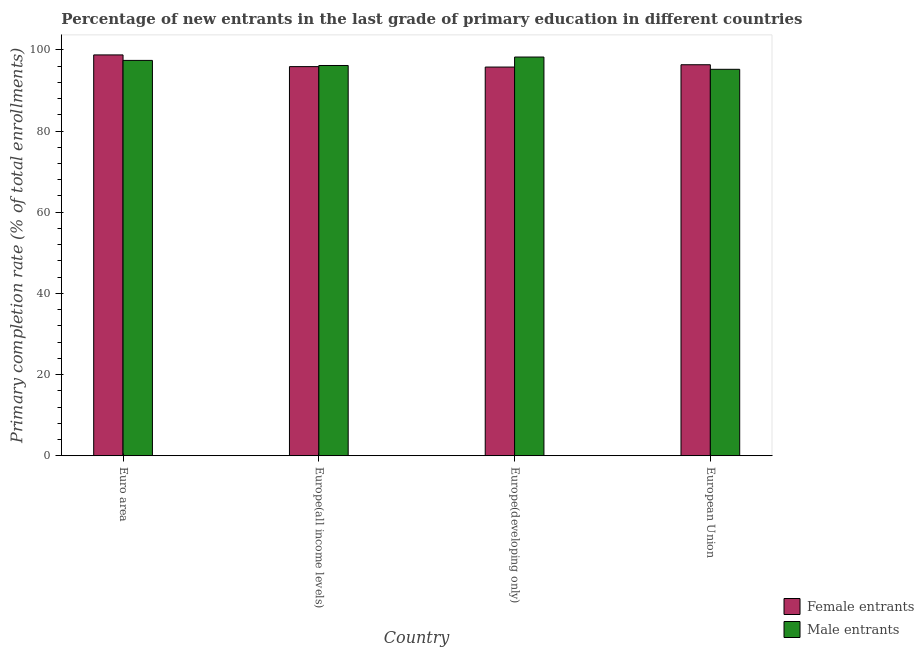Are the number of bars per tick equal to the number of legend labels?
Your answer should be very brief. Yes. Are the number of bars on each tick of the X-axis equal?
Give a very brief answer. Yes. How many bars are there on the 3rd tick from the left?
Provide a short and direct response. 2. How many bars are there on the 3rd tick from the right?
Offer a very short reply. 2. What is the label of the 3rd group of bars from the left?
Your answer should be very brief. Europe(developing only). In how many cases, is the number of bars for a given country not equal to the number of legend labels?
Offer a very short reply. 0. What is the primary completion rate of male entrants in Europe(all income levels)?
Provide a succinct answer. 96.15. Across all countries, what is the maximum primary completion rate of female entrants?
Ensure brevity in your answer.  98.76. Across all countries, what is the minimum primary completion rate of female entrants?
Your answer should be very brief. 95.77. In which country was the primary completion rate of female entrants maximum?
Provide a succinct answer. Euro area. In which country was the primary completion rate of male entrants minimum?
Your response must be concise. European Union. What is the total primary completion rate of female entrants in the graph?
Your response must be concise. 386.74. What is the difference between the primary completion rate of female entrants in Europe(all income levels) and that in Europe(developing only)?
Offer a terse response. 0.11. What is the difference between the primary completion rate of female entrants in Euro area and the primary completion rate of male entrants in Europe(all income levels)?
Provide a succinct answer. 2.61. What is the average primary completion rate of female entrants per country?
Keep it short and to the point. 96.69. What is the difference between the primary completion rate of female entrants and primary completion rate of male entrants in Europe(developing only)?
Provide a short and direct response. -2.47. What is the ratio of the primary completion rate of male entrants in Euro area to that in Europe(developing only)?
Offer a very short reply. 0.99. Is the difference between the primary completion rate of female entrants in Euro area and Europe(developing only) greater than the difference between the primary completion rate of male entrants in Euro area and Europe(developing only)?
Provide a succinct answer. Yes. What is the difference between the highest and the second highest primary completion rate of male entrants?
Your answer should be compact. 0.83. What is the difference between the highest and the lowest primary completion rate of female entrants?
Your response must be concise. 2.99. In how many countries, is the primary completion rate of male entrants greater than the average primary completion rate of male entrants taken over all countries?
Offer a very short reply. 2. What does the 2nd bar from the left in Euro area represents?
Provide a succinct answer. Male entrants. What does the 1st bar from the right in Europe(all income levels) represents?
Offer a very short reply. Male entrants. What is the difference between two consecutive major ticks on the Y-axis?
Give a very brief answer. 20. How many legend labels are there?
Keep it short and to the point. 2. How are the legend labels stacked?
Ensure brevity in your answer.  Vertical. What is the title of the graph?
Offer a very short reply. Percentage of new entrants in the last grade of primary education in different countries. Does "Unregistered firms" appear as one of the legend labels in the graph?
Keep it short and to the point. No. What is the label or title of the X-axis?
Provide a succinct answer. Country. What is the label or title of the Y-axis?
Your answer should be compact. Primary completion rate (% of total enrollments). What is the Primary completion rate (% of total enrollments) in Female entrants in Euro area?
Provide a short and direct response. 98.76. What is the Primary completion rate (% of total enrollments) in Male entrants in Euro area?
Your answer should be compact. 97.41. What is the Primary completion rate (% of total enrollments) of Female entrants in Europe(all income levels)?
Provide a short and direct response. 95.87. What is the Primary completion rate (% of total enrollments) of Male entrants in Europe(all income levels)?
Keep it short and to the point. 96.15. What is the Primary completion rate (% of total enrollments) of Female entrants in Europe(developing only)?
Your answer should be very brief. 95.77. What is the Primary completion rate (% of total enrollments) of Male entrants in Europe(developing only)?
Your response must be concise. 98.23. What is the Primary completion rate (% of total enrollments) of Female entrants in European Union?
Provide a succinct answer. 96.34. What is the Primary completion rate (% of total enrollments) in Male entrants in European Union?
Your answer should be very brief. 95.21. Across all countries, what is the maximum Primary completion rate (% of total enrollments) of Female entrants?
Provide a short and direct response. 98.76. Across all countries, what is the maximum Primary completion rate (% of total enrollments) of Male entrants?
Your response must be concise. 98.23. Across all countries, what is the minimum Primary completion rate (% of total enrollments) of Female entrants?
Provide a short and direct response. 95.77. Across all countries, what is the minimum Primary completion rate (% of total enrollments) of Male entrants?
Your answer should be very brief. 95.21. What is the total Primary completion rate (% of total enrollments) of Female entrants in the graph?
Your response must be concise. 386.74. What is the total Primary completion rate (% of total enrollments) of Male entrants in the graph?
Offer a terse response. 387.01. What is the difference between the Primary completion rate (% of total enrollments) of Female entrants in Euro area and that in Europe(all income levels)?
Provide a short and direct response. 2.88. What is the difference between the Primary completion rate (% of total enrollments) in Male entrants in Euro area and that in Europe(all income levels)?
Provide a succinct answer. 1.25. What is the difference between the Primary completion rate (% of total enrollments) of Female entrants in Euro area and that in Europe(developing only)?
Offer a very short reply. 2.99. What is the difference between the Primary completion rate (% of total enrollments) of Male entrants in Euro area and that in Europe(developing only)?
Make the answer very short. -0.83. What is the difference between the Primary completion rate (% of total enrollments) in Female entrants in Euro area and that in European Union?
Keep it short and to the point. 2.42. What is the difference between the Primary completion rate (% of total enrollments) in Male entrants in Euro area and that in European Union?
Your answer should be compact. 2.19. What is the difference between the Primary completion rate (% of total enrollments) of Female entrants in Europe(all income levels) and that in Europe(developing only)?
Your answer should be compact. 0.11. What is the difference between the Primary completion rate (% of total enrollments) of Male entrants in Europe(all income levels) and that in Europe(developing only)?
Provide a short and direct response. -2.08. What is the difference between the Primary completion rate (% of total enrollments) in Female entrants in Europe(all income levels) and that in European Union?
Keep it short and to the point. -0.46. What is the difference between the Primary completion rate (% of total enrollments) of Male entrants in Europe(all income levels) and that in European Union?
Your answer should be very brief. 0.94. What is the difference between the Primary completion rate (% of total enrollments) in Female entrants in Europe(developing only) and that in European Union?
Provide a succinct answer. -0.57. What is the difference between the Primary completion rate (% of total enrollments) in Male entrants in Europe(developing only) and that in European Union?
Keep it short and to the point. 3.02. What is the difference between the Primary completion rate (% of total enrollments) of Female entrants in Euro area and the Primary completion rate (% of total enrollments) of Male entrants in Europe(all income levels)?
Give a very brief answer. 2.61. What is the difference between the Primary completion rate (% of total enrollments) of Female entrants in Euro area and the Primary completion rate (% of total enrollments) of Male entrants in Europe(developing only)?
Make the answer very short. 0.52. What is the difference between the Primary completion rate (% of total enrollments) of Female entrants in Euro area and the Primary completion rate (% of total enrollments) of Male entrants in European Union?
Offer a terse response. 3.54. What is the difference between the Primary completion rate (% of total enrollments) of Female entrants in Europe(all income levels) and the Primary completion rate (% of total enrollments) of Male entrants in Europe(developing only)?
Your response must be concise. -2.36. What is the difference between the Primary completion rate (% of total enrollments) in Female entrants in Europe(all income levels) and the Primary completion rate (% of total enrollments) in Male entrants in European Union?
Ensure brevity in your answer.  0.66. What is the difference between the Primary completion rate (% of total enrollments) of Female entrants in Europe(developing only) and the Primary completion rate (% of total enrollments) of Male entrants in European Union?
Offer a very short reply. 0.55. What is the average Primary completion rate (% of total enrollments) of Female entrants per country?
Provide a short and direct response. 96.69. What is the average Primary completion rate (% of total enrollments) of Male entrants per country?
Your answer should be very brief. 96.75. What is the difference between the Primary completion rate (% of total enrollments) in Female entrants and Primary completion rate (% of total enrollments) in Male entrants in Euro area?
Your answer should be compact. 1.35. What is the difference between the Primary completion rate (% of total enrollments) in Female entrants and Primary completion rate (% of total enrollments) in Male entrants in Europe(all income levels)?
Ensure brevity in your answer.  -0.28. What is the difference between the Primary completion rate (% of total enrollments) in Female entrants and Primary completion rate (% of total enrollments) in Male entrants in Europe(developing only)?
Keep it short and to the point. -2.47. What is the difference between the Primary completion rate (% of total enrollments) of Female entrants and Primary completion rate (% of total enrollments) of Male entrants in European Union?
Provide a short and direct response. 1.12. What is the ratio of the Primary completion rate (% of total enrollments) in Female entrants in Euro area to that in Europe(all income levels)?
Give a very brief answer. 1.03. What is the ratio of the Primary completion rate (% of total enrollments) of Male entrants in Euro area to that in Europe(all income levels)?
Your answer should be compact. 1.01. What is the ratio of the Primary completion rate (% of total enrollments) of Female entrants in Euro area to that in Europe(developing only)?
Offer a very short reply. 1.03. What is the ratio of the Primary completion rate (% of total enrollments) of Female entrants in Euro area to that in European Union?
Make the answer very short. 1.03. What is the ratio of the Primary completion rate (% of total enrollments) of Female entrants in Europe(all income levels) to that in Europe(developing only)?
Offer a very short reply. 1. What is the ratio of the Primary completion rate (% of total enrollments) of Male entrants in Europe(all income levels) to that in Europe(developing only)?
Your response must be concise. 0.98. What is the ratio of the Primary completion rate (% of total enrollments) in Male entrants in Europe(all income levels) to that in European Union?
Provide a short and direct response. 1.01. What is the ratio of the Primary completion rate (% of total enrollments) of Male entrants in Europe(developing only) to that in European Union?
Your answer should be very brief. 1.03. What is the difference between the highest and the second highest Primary completion rate (% of total enrollments) of Female entrants?
Ensure brevity in your answer.  2.42. What is the difference between the highest and the second highest Primary completion rate (% of total enrollments) of Male entrants?
Give a very brief answer. 0.83. What is the difference between the highest and the lowest Primary completion rate (% of total enrollments) of Female entrants?
Ensure brevity in your answer.  2.99. What is the difference between the highest and the lowest Primary completion rate (% of total enrollments) in Male entrants?
Provide a succinct answer. 3.02. 